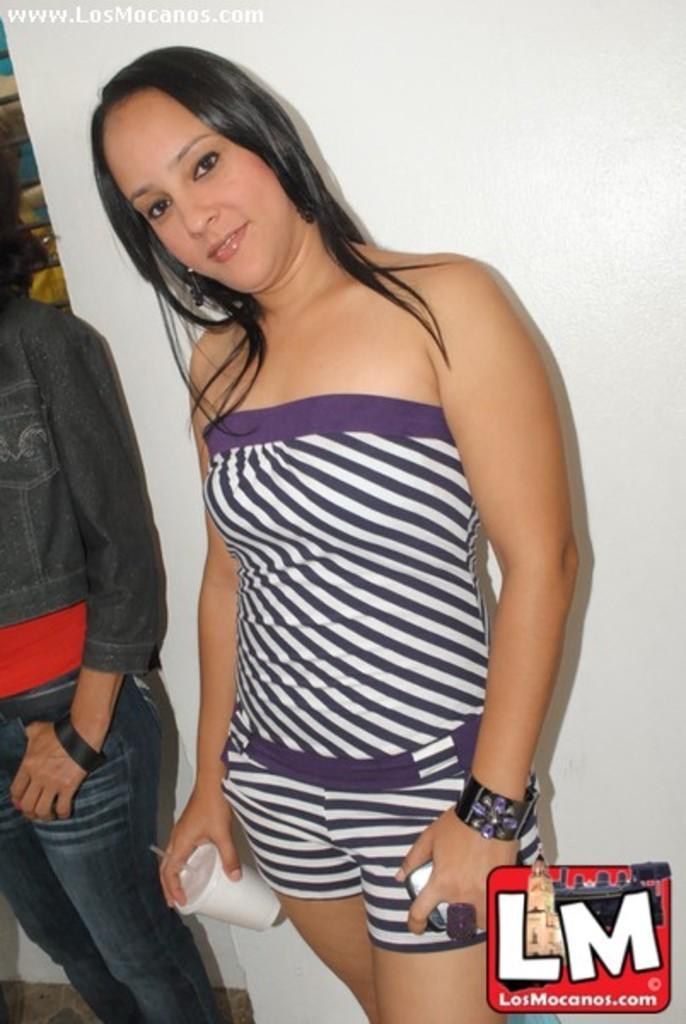Can you describe this image briefly? In the picture we can see a woman standing near the wall holding a glass with the hand and in another hand with a mobile phone and beside her we can see a part of the person standing beside her. 